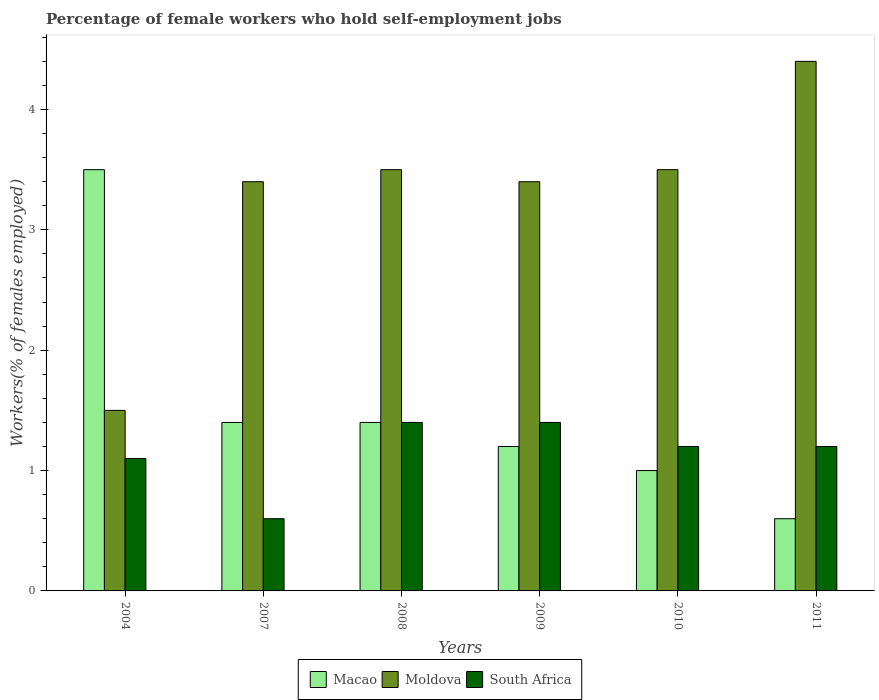How many different coloured bars are there?
Offer a very short reply. 3. Are the number of bars per tick equal to the number of legend labels?
Provide a succinct answer. Yes. Are the number of bars on each tick of the X-axis equal?
Provide a succinct answer. Yes. What is the label of the 5th group of bars from the left?
Give a very brief answer. 2010. What is the percentage of self-employed female workers in Macao in 2010?
Your answer should be very brief. 1. Across all years, what is the maximum percentage of self-employed female workers in South Africa?
Keep it short and to the point. 1.4. Across all years, what is the minimum percentage of self-employed female workers in South Africa?
Make the answer very short. 0.6. In which year was the percentage of self-employed female workers in Macao maximum?
Provide a succinct answer. 2004. What is the total percentage of self-employed female workers in Macao in the graph?
Keep it short and to the point. 9.1. What is the difference between the percentage of self-employed female workers in Moldova in 2010 and that in 2011?
Provide a succinct answer. -0.9. What is the average percentage of self-employed female workers in South Africa per year?
Your response must be concise. 1.15. In the year 2004, what is the difference between the percentage of self-employed female workers in Macao and percentage of self-employed female workers in South Africa?
Make the answer very short. 2.4. In how many years, is the percentage of self-employed female workers in Macao greater than 2.4 %?
Make the answer very short. 1. What is the ratio of the percentage of self-employed female workers in Macao in 2004 to that in 2011?
Provide a succinct answer. 5.83. Is the difference between the percentage of self-employed female workers in Macao in 2008 and 2011 greater than the difference between the percentage of self-employed female workers in South Africa in 2008 and 2011?
Make the answer very short. Yes. What is the difference between the highest and the second highest percentage of self-employed female workers in Macao?
Keep it short and to the point. 2.1. What is the difference between the highest and the lowest percentage of self-employed female workers in Macao?
Your response must be concise. 2.9. In how many years, is the percentage of self-employed female workers in South Africa greater than the average percentage of self-employed female workers in South Africa taken over all years?
Offer a very short reply. 4. What does the 3rd bar from the left in 2010 represents?
Give a very brief answer. South Africa. What does the 2nd bar from the right in 2008 represents?
Provide a succinct answer. Moldova. Is it the case that in every year, the sum of the percentage of self-employed female workers in Moldova and percentage of self-employed female workers in South Africa is greater than the percentage of self-employed female workers in Macao?
Provide a succinct answer. No. How many bars are there?
Make the answer very short. 18. Are all the bars in the graph horizontal?
Your answer should be compact. No. How many years are there in the graph?
Offer a very short reply. 6. What is the difference between two consecutive major ticks on the Y-axis?
Provide a succinct answer. 1. Are the values on the major ticks of Y-axis written in scientific E-notation?
Your response must be concise. No. Where does the legend appear in the graph?
Provide a succinct answer. Bottom center. How are the legend labels stacked?
Give a very brief answer. Horizontal. What is the title of the graph?
Give a very brief answer. Percentage of female workers who hold self-employment jobs. Does "Denmark" appear as one of the legend labels in the graph?
Make the answer very short. No. What is the label or title of the Y-axis?
Keep it short and to the point. Workers(% of females employed). What is the Workers(% of females employed) in Moldova in 2004?
Make the answer very short. 1.5. What is the Workers(% of females employed) of South Africa in 2004?
Offer a terse response. 1.1. What is the Workers(% of females employed) in Macao in 2007?
Offer a terse response. 1.4. What is the Workers(% of females employed) in Moldova in 2007?
Keep it short and to the point. 3.4. What is the Workers(% of females employed) in South Africa in 2007?
Your response must be concise. 0.6. What is the Workers(% of females employed) in Macao in 2008?
Make the answer very short. 1.4. What is the Workers(% of females employed) of Moldova in 2008?
Keep it short and to the point. 3.5. What is the Workers(% of females employed) of South Africa in 2008?
Ensure brevity in your answer.  1.4. What is the Workers(% of females employed) of Macao in 2009?
Provide a short and direct response. 1.2. What is the Workers(% of females employed) of Moldova in 2009?
Keep it short and to the point. 3.4. What is the Workers(% of females employed) in South Africa in 2009?
Make the answer very short. 1.4. What is the Workers(% of females employed) of Macao in 2010?
Offer a terse response. 1. What is the Workers(% of females employed) of Moldova in 2010?
Your answer should be very brief. 3.5. What is the Workers(% of females employed) in South Africa in 2010?
Give a very brief answer. 1.2. What is the Workers(% of females employed) in Macao in 2011?
Ensure brevity in your answer.  0.6. What is the Workers(% of females employed) of Moldova in 2011?
Provide a short and direct response. 4.4. What is the Workers(% of females employed) of South Africa in 2011?
Make the answer very short. 1.2. Across all years, what is the maximum Workers(% of females employed) of Macao?
Your response must be concise. 3.5. Across all years, what is the maximum Workers(% of females employed) in Moldova?
Offer a very short reply. 4.4. Across all years, what is the maximum Workers(% of females employed) in South Africa?
Keep it short and to the point. 1.4. Across all years, what is the minimum Workers(% of females employed) in Macao?
Your answer should be very brief. 0.6. Across all years, what is the minimum Workers(% of females employed) in South Africa?
Provide a succinct answer. 0.6. What is the total Workers(% of females employed) of Macao in the graph?
Keep it short and to the point. 9.1. What is the difference between the Workers(% of females employed) in Macao in 2004 and that in 2008?
Offer a terse response. 2.1. What is the difference between the Workers(% of females employed) of Macao in 2004 and that in 2009?
Ensure brevity in your answer.  2.3. What is the difference between the Workers(% of females employed) of Macao in 2004 and that in 2010?
Offer a very short reply. 2.5. What is the difference between the Workers(% of females employed) in South Africa in 2004 and that in 2011?
Give a very brief answer. -0.1. What is the difference between the Workers(% of females employed) of South Africa in 2007 and that in 2008?
Provide a short and direct response. -0.8. What is the difference between the Workers(% of females employed) in South Africa in 2007 and that in 2009?
Your response must be concise. -0.8. What is the difference between the Workers(% of females employed) of Macao in 2007 and that in 2010?
Offer a terse response. 0.4. What is the difference between the Workers(% of females employed) in South Africa in 2007 and that in 2010?
Your answer should be very brief. -0.6. What is the difference between the Workers(% of females employed) of Macao in 2007 and that in 2011?
Provide a succinct answer. 0.8. What is the difference between the Workers(% of females employed) in Moldova in 2007 and that in 2011?
Give a very brief answer. -1. What is the difference between the Workers(% of females employed) in Moldova in 2008 and that in 2009?
Provide a short and direct response. 0.1. What is the difference between the Workers(% of females employed) in Moldova in 2008 and that in 2010?
Your answer should be very brief. 0. What is the difference between the Workers(% of females employed) in Macao in 2008 and that in 2011?
Offer a terse response. 0.8. What is the difference between the Workers(% of females employed) in Moldova in 2008 and that in 2011?
Your response must be concise. -0.9. What is the difference between the Workers(% of females employed) in South Africa in 2008 and that in 2011?
Provide a succinct answer. 0.2. What is the difference between the Workers(% of females employed) in Macao in 2009 and that in 2010?
Provide a succinct answer. 0.2. What is the difference between the Workers(% of females employed) in Moldova in 2009 and that in 2010?
Make the answer very short. -0.1. What is the difference between the Workers(% of females employed) in Macao in 2009 and that in 2011?
Provide a succinct answer. 0.6. What is the difference between the Workers(% of females employed) of Macao in 2010 and that in 2011?
Provide a succinct answer. 0.4. What is the difference between the Workers(% of females employed) of South Africa in 2010 and that in 2011?
Your answer should be compact. 0. What is the difference between the Workers(% of females employed) of Macao in 2004 and the Workers(% of females employed) of South Africa in 2007?
Provide a succinct answer. 2.9. What is the difference between the Workers(% of females employed) of Macao in 2004 and the Workers(% of females employed) of Moldova in 2008?
Provide a succinct answer. 0. What is the difference between the Workers(% of females employed) of Macao in 2004 and the Workers(% of females employed) of South Africa in 2008?
Offer a very short reply. 2.1. What is the difference between the Workers(% of females employed) in Moldova in 2004 and the Workers(% of females employed) in South Africa in 2008?
Offer a very short reply. 0.1. What is the difference between the Workers(% of females employed) in Macao in 2004 and the Workers(% of females employed) in Moldova in 2009?
Your answer should be compact. 0.1. What is the difference between the Workers(% of females employed) of Moldova in 2004 and the Workers(% of females employed) of South Africa in 2009?
Your answer should be very brief. 0.1. What is the difference between the Workers(% of females employed) of Macao in 2004 and the Workers(% of females employed) of Moldova in 2011?
Your answer should be very brief. -0.9. What is the difference between the Workers(% of females employed) in Macao in 2004 and the Workers(% of females employed) in South Africa in 2011?
Your answer should be compact. 2.3. What is the difference between the Workers(% of females employed) of Moldova in 2004 and the Workers(% of females employed) of South Africa in 2011?
Your answer should be compact. 0.3. What is the difference between the Workers(% of females employed) in Macao in 2007 and the Workers(% of females employed) in Moldova in 2008?
Keep it short and to the point. -2.1. What is the difference between the Workers(% of females employed) in Macao in 2007 and the Workers(% of females employed) in South Africa in 2008?
Offer a very short reply. 0. What is the difference between the Workers(% of females employed) of Moldova in 2007 and the Workers(% of females employed) of South Africa in 2008?
Provide a short and direct response. 2. What is the difference between the Workers(% of females employed) in Macao in 2007 and the Workers(% of females employed) in Moldova in 2010?
Offer a very short reply. -2.1. What is the difference between the Workers(% of females employed) in Macao in 2007 and the Workers(% of females employed) in South Africa in 2010?
Your response must be concise. 0.2. What is the difference between the Workers(% of females employed) of Moldova in 2007 and the Workers(% of females employed) of South Africa in 2010?
Your response must be concise. 2.2. What is the difference between the Workers(% of females employed) of Macao in 2008 and the Workers(% of females employed) of Moldova in 2009?
Ensure brevity in your answer.  -2. What is the difference between the Workers(% of females employed) of Macao in 2008 and the Workers(% of females employed) of Moldova in 2010?
Provide a short and direct response. -2.1. What is the difference between the Workers(% of females employed) of Macao in 2008 and the Workers(% of females employed) of South Africa in 2010?
Offer a terse response. 0.2. What is the difference between the Workers(% of females employed) in Moldova in 2008 and the Workers(% of females employed) in South Africa in 2011?
Your response must be concise. 2.3. What is the difference between the Workers(% of females employed) in Macao in 2009 and the Workers(% of females employed) in Moldova in 2010?
Your answer should be very brief. -2.3. What is the difference between the Workers(% of females employed) of Moldova in 2009 and the Workers(% of females employed) of South Africa in 2010?
Keep it short and to the point. 2.2. What is the difference between the Workers(% of females employed) in Moldova in 2009 and the Workers(% of females employed) in South Africa in 2011?
Offer a very short reply. 2.2. What is the difference between the Workers(% of females employed) of Macao in 2010 and the Workers(% of females employed) of South Africa in 2011?
Ensure brevity in your answer.  -0.2. What is the average Workers(% of females employed) of Macao per year?
Provide a succinct answer. 1.52. What is the average Workers(% of females employed) of Moldova per year?
Keep it short and to the point. 3.28. What is the average Workers(% of females employed) of South Africa per year?
Give a very brief answer. 1.15. In the year 2004, what is the difference between the Workers(% of females employed) in Macao and Workers(% of females employed) in Moldova?
Ensure brevity in your answer.  2. In the year 2004, what is the difference between the Workers(% of females employed) of Moldova and Workers(% of females employed) of South Africa?
Your response must be concise. 0.4. In the year 2007, what is the difference between the Workers(% of females employed) in Moldova and Workers(% of females employed) in South Africa?
Keep it short and to the point. 2.8. In the year 2008, what is the difference between the Workers(% of females employed) in Moldova and Workers(% of females employed) in South Africa?
Keep it short and to the point. 2.1. In the year 2010, what is the difference between the Workers(% of females employed) in Macao and Workers(% of females employed) in Moldova?
Provide a short and direct response. -2.5. In the year 2010, what is the difference between the Workers(% of females employed) of Moldova and Workers(% of females employed) of South Africa?
Your answer should be very brief. 2.3. In the year 2011, what is the difference between the Workers(% of females employed) in Moldova and Workers(% of females employed) in South Africa?
Make the answer very short. 3.2. What is the ratio of the Workers(% of females employed) in Moldova in 2004 to that in 2007?
Offer a very short reply. 0.44. What is the ratio of the Workers(% of females employed) of South Africa in 2004 to that in 2007?
Provide a short and direct response. 1.83. What is the ratio of the Workers(% of females employed) in Macao in 2004 to that in 2008?
Give a very brief answer. 2.5. What is the ratio of the Workers(% of females employed) of Moldova in 2004 to that in 2008?
Ensure brevity in your answer.  0.43. What is the ratio of the Workers(% of females employed) in South Africa in 2004 to that in 2008?
Your answer should be compact. 0.79. What is the ratio of the Workers(% of females employed) of Macao in 2004 to that in 2009?
Provide a short and direct response. 2.92. What is the ratio of the Workers(% of females employed) in Moldova in 2004 to that in 2009?
Offer a terse response. 0.44. What is the ratio of the Workers(% of females employed) of South Africa in 2004 to that in 2009?
Offer a very short reply. 0.79. What is the ratio of the Workers(% of females employed) of Moldova in 2004 to that in 2010?
Keep it short and to the point. 0.43. What is the ratio of the Workers(% of females employed) in Macao in 2004 to that in 2011?
Your response must be concise. 5.83. What is the ratio of the Workers(% of females employed) of Moldova in 2004 to that in 2011?
Your answer should be compact. 0.34. What is the ratio of the Workers(% of females employed) of South Africa in 2004 to that in 2011?
Keep it short and to the point. 0.92. What is the ratio of the Workers(% of females employed) in Moldova in 2007 to that in 2008?
Your response must be concise. 0.97. What is the ratio of the Workers(% of females employed) of South Africa in 2007 to that in 2008?
Keep it short and to the point. 0.43. What is the ratio of the Workers(% of females employed) in Macao in 2007 to that in 2009?
Make the answer very short. 1.17. What is the ratio of the Workers(% of females employed) in Moldova in 2007 to that in 2009?
Make the answer very short. 1. What is the ratio of the Workers(% of females employed) of South Africa in 2007 to that in 2009?
Offer a very short reply. 0.43. What is the ratio of the Workers(% of females employed) in Moldova in 2007 to that in 2010?
Provide a short and direct response. 0.97. What is the ratio of the Workers(% of females employed) of South Africa in 2007 to that in 2010?
Your answer should be very brief. 0.5. What is the ratio of the Workers(% of females employed) in Macao in 2007 to that in 2011?
Provide a short and direct response. 2.33. What is the ratio of the Workers(% of females employed) of Moldova in 2007 to that in 2011?
Your answer should be compact. 0.77. What is the ratio of the Workers(% of females employed) of Macao in 2008 to that in 2009?
Keep it short and to the point. 1.17. What is the ratio of the Workers(% of females employed) in Moldova in 2008 to that in 2009?
Your response must be concise. 1.03. What is the ratio of the Workers(% of females employed) in South Africa in 2008 to that in 2009?
Offer a terse response. 1. What is the ratio of the Workers(% of females employed) of Macao in 2008 to that in 2011?
Ensure brevity in your answer.  2.33. What is the ratio of the Workers(% of females employed) of Moldova in 2008 to that in 2011?
Make the answer very short. 0.8. What is the ratio of the Workers(% of females employed) of Moldova in 2009 to that in 2010?
Offer a very short reply. 0.97. What is the ratio of the Workers(% of females employed) of Macao in 2009 to that in 2011?
Give a very brief answer. 2. What is the ratio of the Workers(% of females employed) of Moldova in 2009 to that in 2011?
Provide a short and direct response. 0.77. What is the ratio of the Workers(% of females employed) in South Africa in 2009 to that in 2011?
Provide a succinct answer. 1.17. What is the ratio of the Workers(% of females employed) of Moldova in 2010 to that in 2011?
Give a very brief answer. 0.8. What is the difference between the highest and the second highest Workers(% of females employed) in Macao?
Provide a succinct answer. 2.1. What is the difference between the highest and the second highest Workers(% of females employed) in Moldova?
Your answer should be compact. 0.9. What is the difference between the highest and the lowest Workers(% of females employed) in Moldova?
Your answer should be very brief. 2.9. 